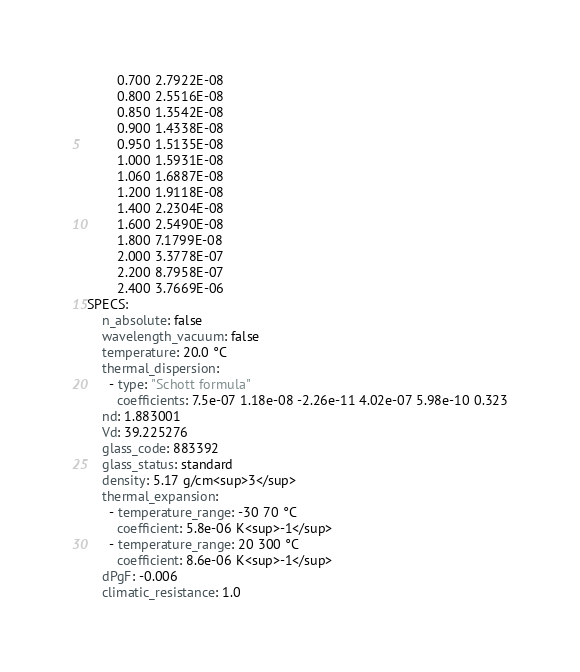Convert code to text. <code><loc_0><loc_0><loc_500><loc_500><_YAML_>        0.700 2.7922E-08
        0.800 2.5516E-08
        0.850 1.3542E-08
        0.900 1.4338E-08
        0.950 1.5135E-08
        1.000 1.5931E-08
        1.060 1.6887E-08
        1.200 1.9118E-08
        1.400 2.2304E-08
        1.600 2.5490E-08
        1.800 7.1799E-08
        2.000 3.3778E-07
        2.200 8.7958E-07
        2.400 3.7669E-06
SPECS:
    n_absolute: false
    wavelength_vacuum: false
    temperature: 20.0 °C
    thermal_dispersion:
      - type: "Schott formula"
        coefficients: 7.5e-07 1.18e-08 -2.26e-11 4.02e-07 5.98e-10 0.323
    nd: 1.883001
    Vd: 39.225276
    glass_code: 883392
    glass_status: standard
    density: 5.17 g/cm<sup>3</sup>
    thermal_expansion:
      - temperature_range: -30 70 °C
        coefficient: 5.8e-06 K<sup>-1</sup>
      - temperature_range: 20 300 °C
        coefficient: 8.6e-06 K<sup>-1</sup>
    dPgF: -0.006
    climatic_resistance: 1.0
</code> 